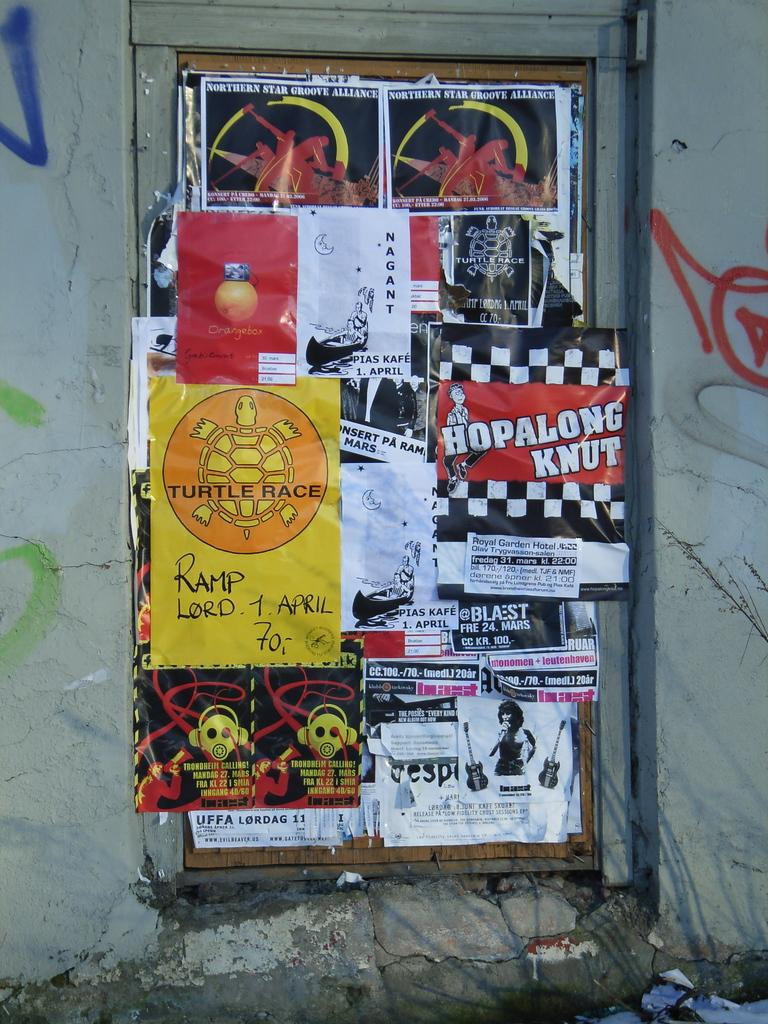<image>
Summarize the visual content of the image. The bulletin board is overflowing with ads like one for Hopalong Knut. 